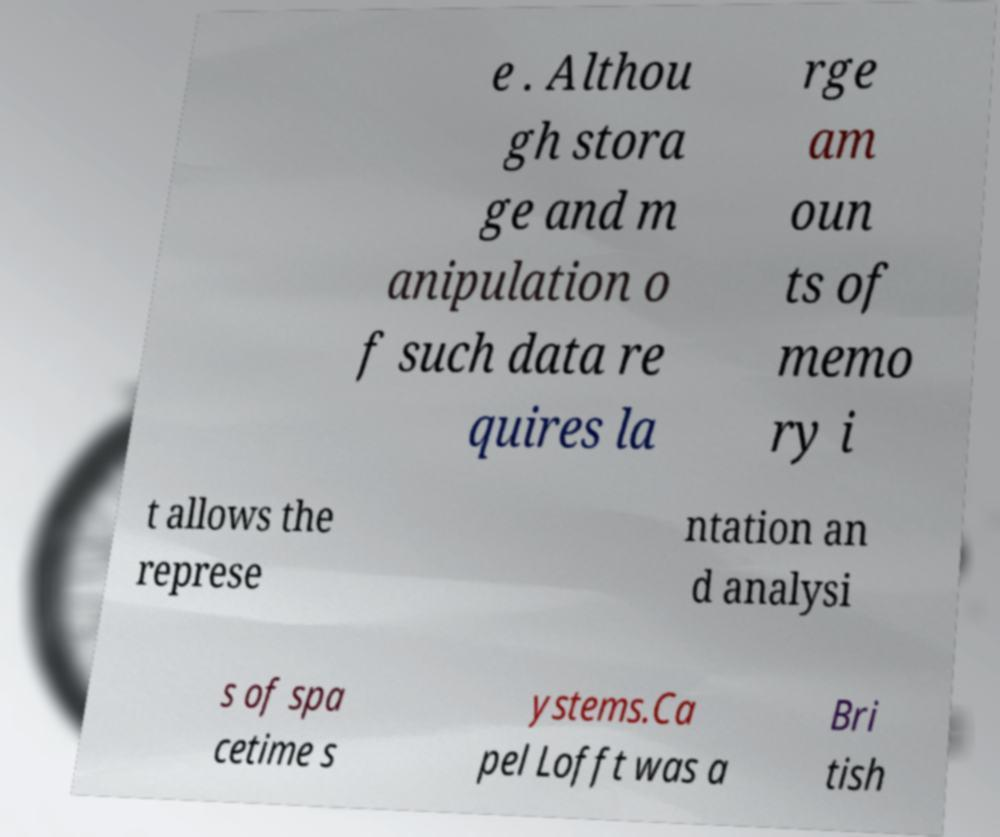Please identify and transcribe the text found in this image. e . Althou gh stora ge and m anipulation o f such data re quires la rge am oun ts of memo ry i t allows the represe ntation an d analysi s of spa cetime s ystems.Ca pel Lofft was a Bri tish 